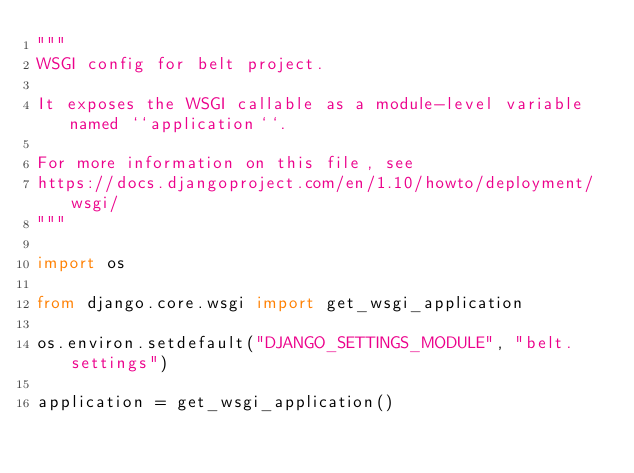<code> <loc_0><loc_0><loc_500><loc_500><_Python_>"""
WSGI config for belt project.

It exposes the WSGI callable as a module-level variable named ``application``.

For more information on this file, see
https://docs.djangoproject.com/en/1.10/howto/deployment/wsgi/
"""

import os

from django.core.wsgi import get_wsgi_application

os.environ.setdefault("DJANGO_SETTINGS_MODULE", "belt.settings")

application = get_wsgi_application()
</code> 